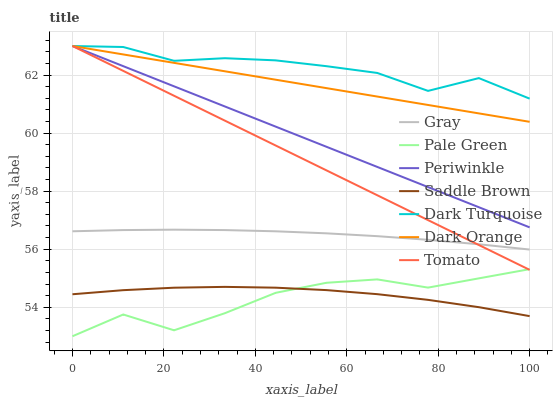Does Pale Green have the minimum area under the curve?
Answer yes or no. Yes. Does Dark Turquoise have the maximum area under the curve?
Answer yes or no. Yes. Does Dark Orange have the minimum area under the curve?
Answer yes or no. No. Does Dark Orange have the maximum area under the curve?
Answer yes or no. No. Is Dark Orange the smoothest?
Answer yes or no. Yes. Is Pale Green the roughest?
Answer yes or no. Yes. Is Gray the smoothest?
Answer yes or no. No. Is Gray the roughest?
Answer yes or no. No. Does Pale Green have the lowest value?
Answer yes or no. Yes. Does Dark Orange have the lowest value?
Answer yes or no. No. Does Periwinkle have the highest value?
Answer yes or no. Yes. Does Gray have the highest value?
Answer yes or no. No. Is Saddle Brown less than Periwinkle?
Answer yes or no. Yes. Is Periwinkle greater than Saddle Brown?
Answer yes or no. Yes. Does Dark Orange intersect Tomato?
Answer yes or no. Yes. Is Dark Orange less than Tomato?
Answer yes or no. No. Is Dark Orange greater than Tomato?
Answer yes or no. No. Does Saddle Brown intersect Periwinkle?
Answer yes or no. No. 